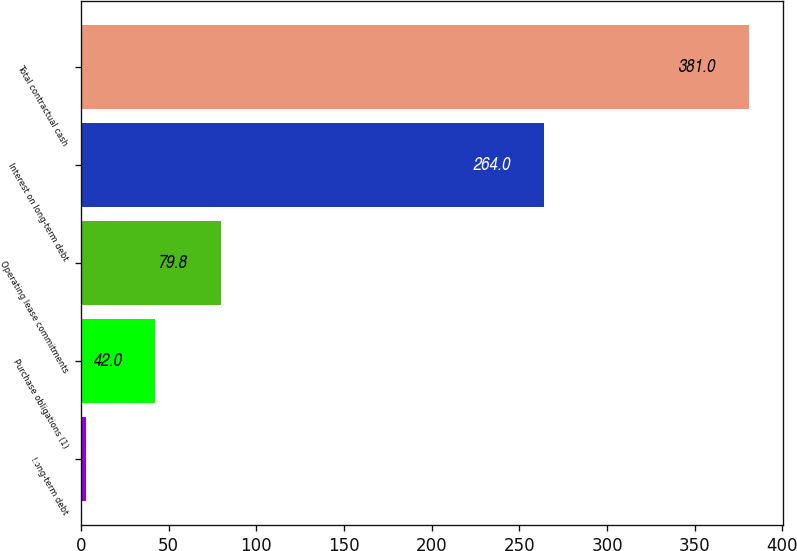Convert chart. <chart><loc_0><loc_0><loc_500><loc_500><bar_chart><fcel>Long-term debt<fcel>Purchase obligations (1)<fcel>Operating lease commitments<fcel>Interest on long-term debt<fcel>Total contractual cash<nl><fcel>3<fcel>42<fcel>79.8<fcel>264<fcel>381<nl></chart> 